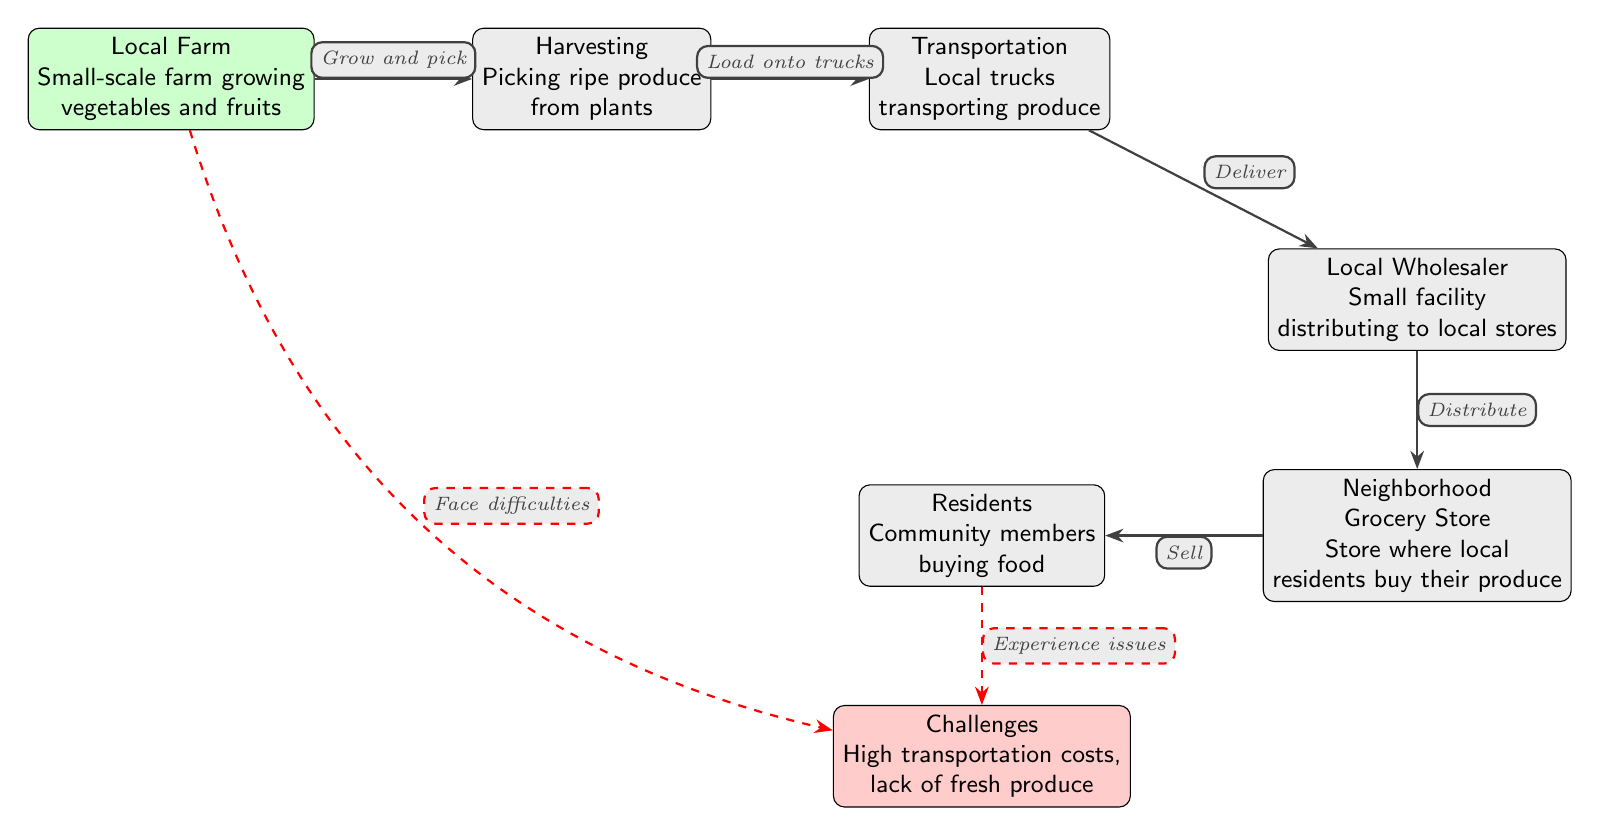What are the two primary functions of the Local Farm? The Local Farm node states it engages in growing vegetables and fruits as its primary functions. These activities are essential for starting the food chain.
Answer: Small-scale farm growing vegetables and fruits How many edges are in the diagram? To determine the number of edges, count each line that connects nodes, which in this case is five edges connecting the farm to the customers.
Answer: 5 What do residents do at the Neighborhood Grocery Store? According to the Neighborhood Grocery Store node, residents engage in buying food at this location, emphasizing its role in food accessibility.
Answer: Buy food Which node represents the last step before produce reaches customers? The Neighborhood Grocery Store node is the final node before the interaction with customers, serving as the retail point for produce.
Answer: Neighborhood Grocery Store What challenges are mentioned that affect both farmers and residents? The diagram states there are challenges related to high transportation costs and a lack of fresh produce, which impact both farmers and residents within the community.
Answer: High transportation costs, lack of fresh produce What is the connection between transportation and wholesale? The Transportation node indicates that local trucks deliver the produce to the Local Wholesaler, serving as an intermediary in the supply chain.
Answer: Deliver How do residents experience issues regarding their food access? Residents face challenges that involve high transportation costs and a lack of fresh produce, making access to healthy food options difficult.
Answer: Experience issues 